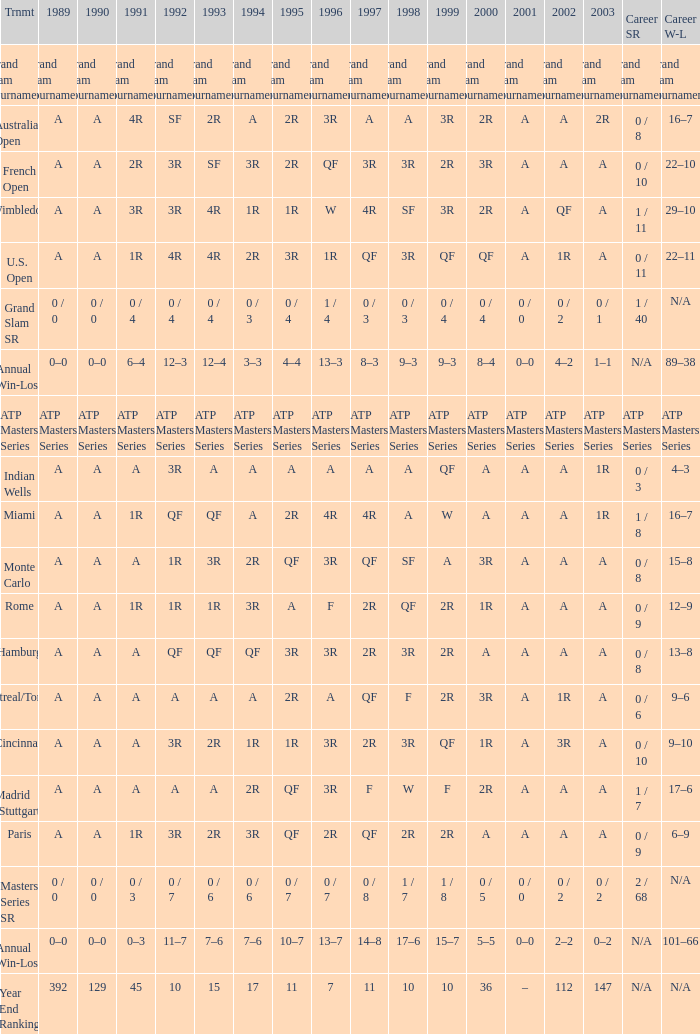What was the career SR with a value of A in 1980 and F in 1997? 1 / 7. 